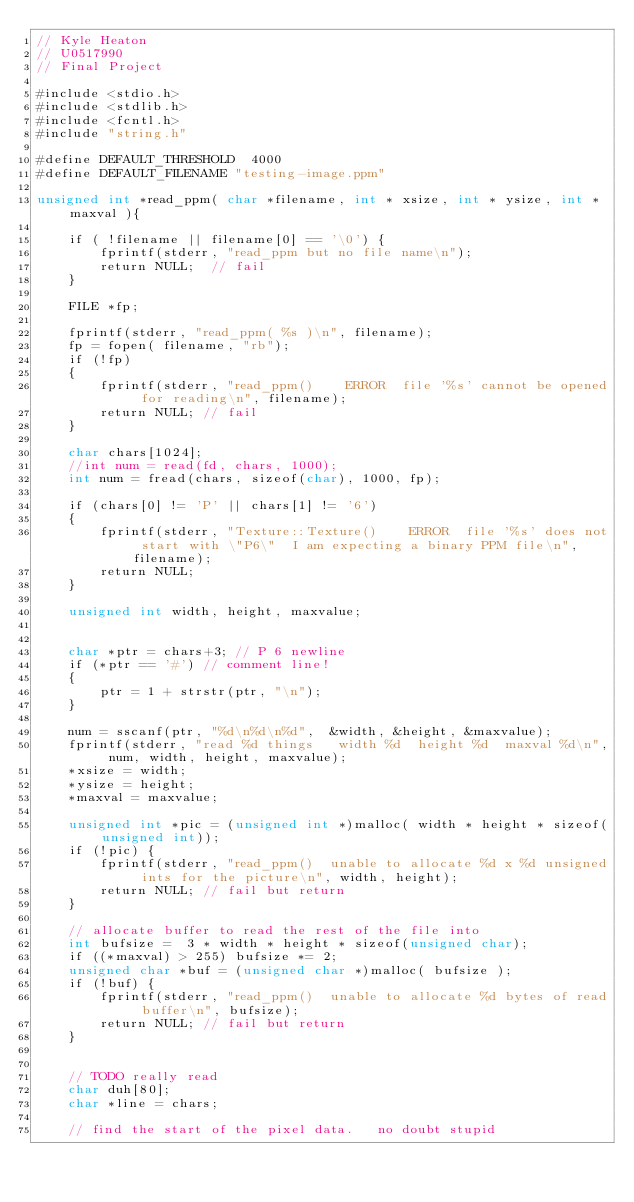Convert code to text. <code><loc_0><loc_0><loc_500><loc_500><_Cuda_>// Kyle Heaton
// U0517990
// Final Project

#include <stdio.h>
#include <stdlib.h>
#include <fcntl.h>
#include "string.h"

#define DEFAULT_THRESHOLD  4000
#define DEFAULT_FILENAME "testing-image.ppm"

unsigned int *read_ppm( char *filename, int * xsize, int * ysize, int *maxval ){
  
	if ( !filename || filename[0] == '\0') {
		fprintf(stderr, "read_ppm but no file name\n");
		return NULL;  // fail
	}

  	FILE *fp;

	fprintf(stderr, "read_ppm( %s )\n", filename);
	fp = fopen( filename, "rb");
	if (!fp) 
	{
		fprintf(stderr, "read_ppm()    ERROR  file '%s' cannot be opened for reading\n", filename);
		return NULL; // fail 
	}

	char chars[1024];
	//int num = read(fd, chars, 1000);
	int num = fread(chars, sizeof(char), 1000, fp);

	if (chars[0] != 'P' || chars[1] != '6') 
	{
		fprintf(stderr, "Texture::Texture()    ERROR  file '%s' does not start with \"P6\"  I am expecting a binary PPM file\n", filename);
		return NULL;
	}

	unsigned int width, height, maxvalue;


	char *ptr = chars+3; // P 6 newline
	if (*ptr == '#') // comment line! 
	{
		ptr = 1 + strstr(ptr, "\n");
	}

	num = sscanf(ptr, "%d\n%d\n%d",  &width, &height, &maxvalue);
	fprintf(stderr, "read %d things   width %d  height %d  maxval %d\n", num, width, height, maxvalue);  
	*xsize = width;
	*ysize = height;
	*maxval = maxvalue;
  
	unsigned int *pic = (unsigned int *)malloc( width * height * sizeof(unsigned int));
	if (!pic) {
		fprintf(stderr, "read_ppm()  unable to allocate %d x %d unsigned ints for the picture\n", width, height);
		return NULL; // fail but return
	}

	// allocate buffer to read the rest of the file into
	int bufsize =  3 * width * height * sizeof(unsigned char);
	if ((*maxval) > 255) bufsize *= 2;
	unsigned char *buf = (unsigned char *)malloc( bufsize );
	if (!buf) {
		fprintf(stderr, "read_ppm()  unable to allocate %d bytes of read buffer\n", bufsize);
		return NULL; // fail but return
	}


	// TODO really read
	char duh[80];
	char *line = chars;

	// find the start of the pixel data.   no doubt stupid</code> 